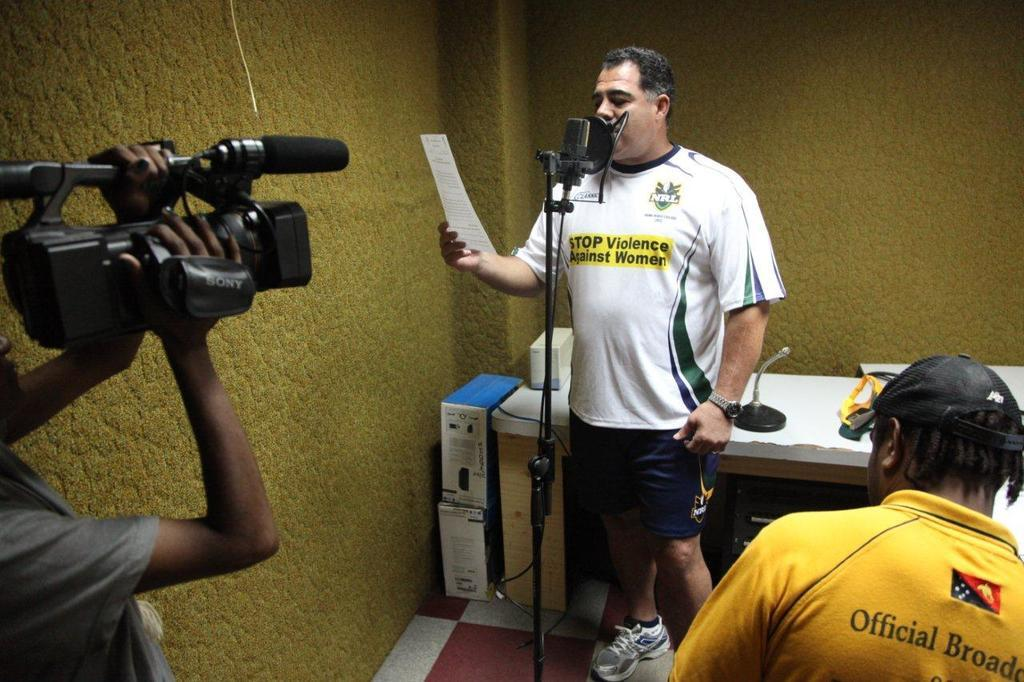<image>
Offer a succinct explanation of the picture presented. A man is reading a paper and STOP Violence Against Women" is printed on his shirt. 